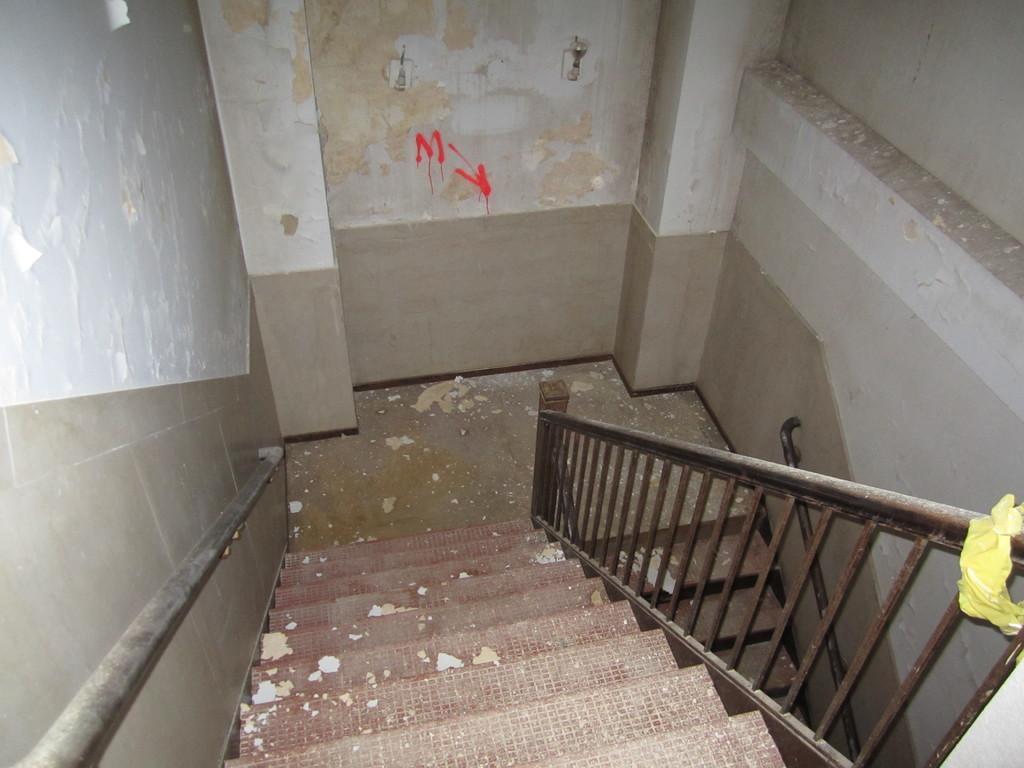Can you describe this image briefly? In this image we can see the stairs, beside that we can see the metal fence. And we can see the wall and some text written on it. 